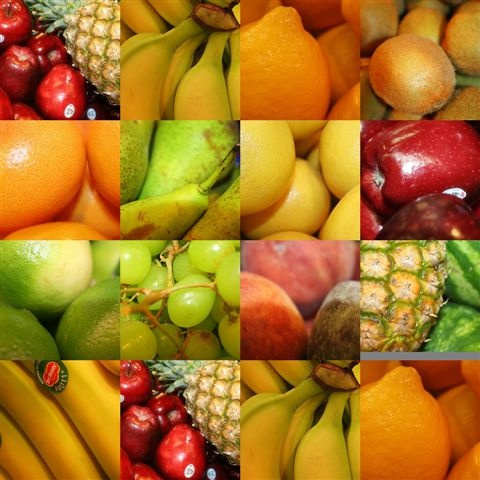Describe the objects in this image and their specific colors. I can see orange in brown, red, orange, and maroon tones, orange in brown, red, orange, and maroon tones, orange in brown, orange, and red tones, banana in brown, olive, orange, and maroon tones, and apple in brown, salmon, and maroon tones in this image. 